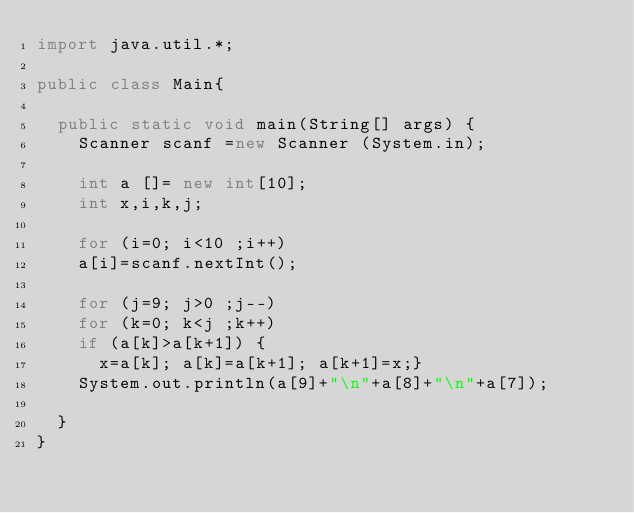Convert code to text. <code><loc_0><loc_0><loc_500><loc_500><_Java_>import java.util.*;

public class Main{

	public static void main(String[] args) {
		Scanner scanf =new Scanner (System.in);
		
		int a []= new int[10];
		int x,i,k,j;
		
		for (i=0; i<10 ;i++)
		a[i]=scanf.nextInt();
		
		for (j=9; j>0 ;j--)
		for (k=0; k<j ;k++)
		if (a[k]>a[k+1]) {
			x=a[k]; a[k]=a[k+1]; a[k+1]=x;} 
		System.out.println(a[9]+"\n"+a[8]+"\n"+a[7]);
		
	}
}</code> 